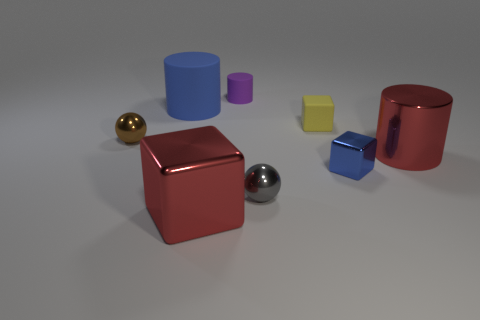There is a large thing that is the same color as the big shiny cylinder; what shape is it?
Offer a terse response. Cube. Is there a gray object made of the same material as the purple cylinder?
Your answer should be very brief. No. What is the shape of the tiny gray metal thing?
Offer a terse response. Sphere. How many large green matte objects are there?
Give a very brief answer. 0. The matte thing that is on the left side of the big red object that is to the left of the small purple cylinder is what color?
Provide a short and direct response. Blue. What color is the other sphere that is the same size as the gray ball?
Provide a succinct answer. Brown. Are there any tiny blocks that have the same color as the big rubber cylinder?
Give a very brief answer. Yes. Are any large red shiny objects visible?
Give a very brief answer. Yes. The blue object that is in front of the brown sphere has what shape?
Make the answer very short. Cube. What number of metallic objects are right of the tiny yellow matte block and on the left side of the large red metal cylinder?
Ensure brevity in your answer.  1. 